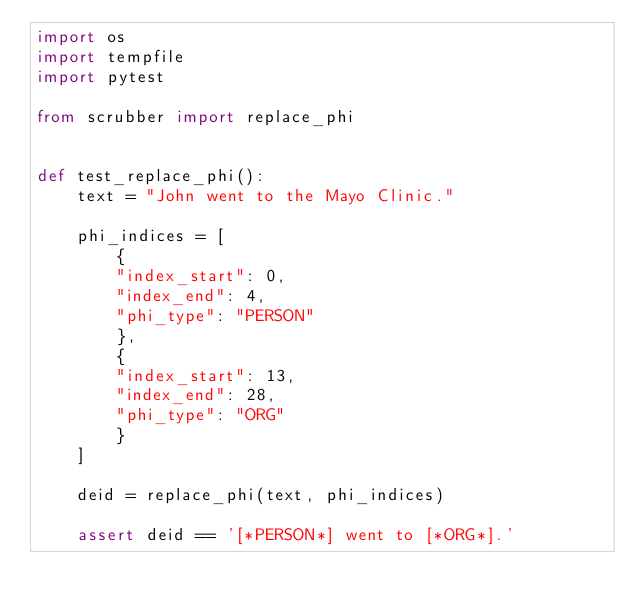<code> <loc_0><loc_0><loc_500><loc_500><_Python_>import os
import tempfile
import pytest

from scrubber import replace_phi


def test_replace_phi():
    text = "John went to the Mayo Clinic."

    phi_indices = [
        {
        "index_start": 0,
        "index_end": 4,
        "phi_type": "PERSON"
        },
        {
        "index_start": 13,
        "index_end": 28,
        "phi_type": "ORG"
        }
    ]

    deid = replace_phi(text, phi_indices)

    assert deid == '[*PERSON*] went to [*ORG*].'
</code> 